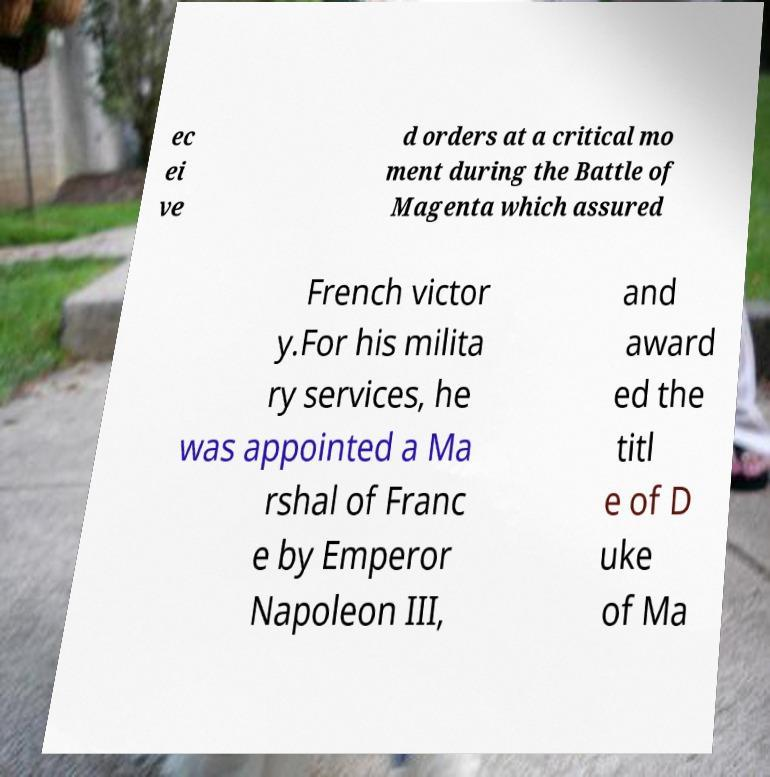There's text embedded in this image that I need extracted. Can you transcribe it verbatim? ec ei ve d orders at a critical mo ment during the Battle of Magenta which assured French victor y.For his milita ry services, he was appointed a Ma rshal of Franc e by Emperor Napoleon III, and award ed the titl e of D uke of Ma 